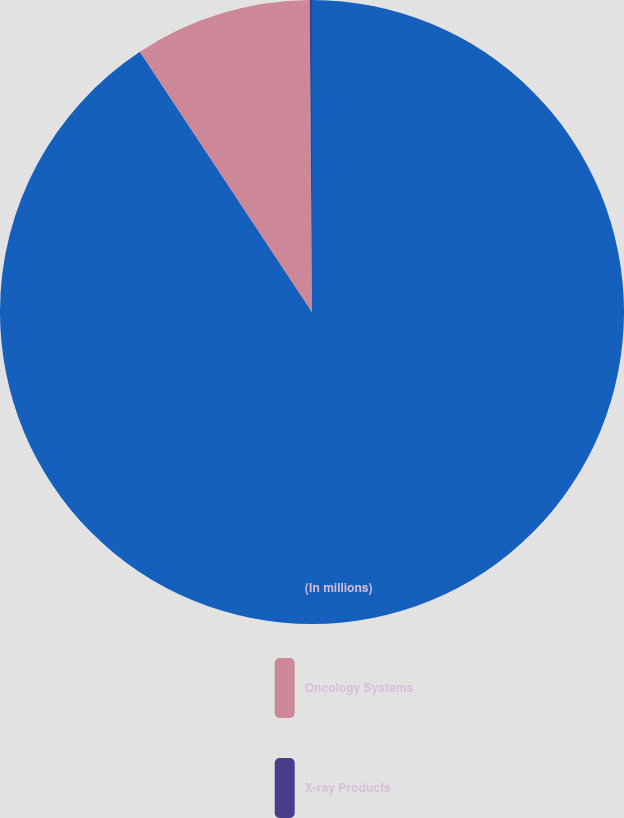Convert chart. <chart><loc_0><loc_0><loc_500><loc_500><pie_chart><fcel>(In millions)<fcel>Oncology Systems<fcel>X-ray Products<nl><fcel>90.7%<fcel>9.18%<fcel>0.12%<nl></chart> 